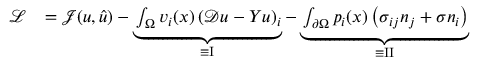<formula> <loc_0><loc_0><loc_500><loc_500>\begin{array} { r l } { \mathcal { L } } & { = \mathcal { J } ( u , \hat { u } ) - \underbrace { \int _ { \Omega } v _ { i } ( x ) \left ( \mathcal { D } u - Y u \right ) _ { i } } _ { \equiv I } - \underbrace { \int _ { \partial \Omega } p _ { i } ( x ) \left ( \sigma _ { i j } n _ { j } + \sigma n _ { i } \right ) } _ { \equiv I I } } \end{array}</formula> 